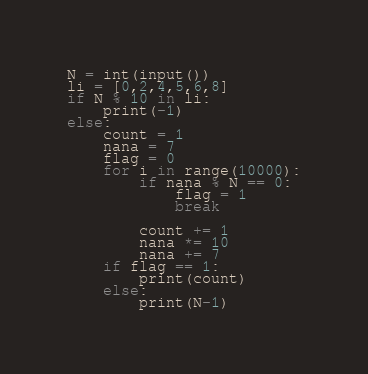<code> <loc_0><loc_0><loc_500><loc_500><_Python_>N = int(input())
li = [0,2,4,5,6,8]
if N % 10 in li:
    print(-1)
else:
    count = 1
    nana = 7
    flag = 0
    for i in range(10000):
        if nana % N == 0:
            flag = 1
            break

        count += 1
        nana *= 10
        nana += 7
    if flag == 1:
        print(count)
    else:
        print(N-1)</code> 